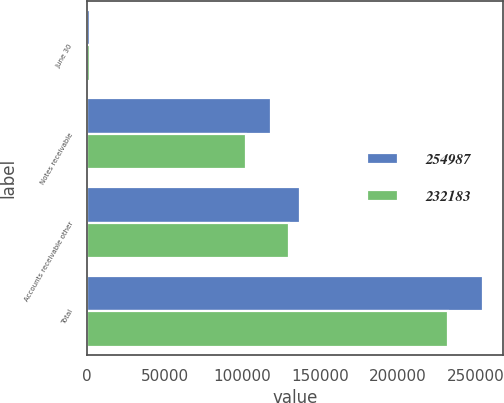Convert chart to OTSL. <chart><loc_0><loc_0><loc_500><loc_500><stacked_bar_chart><ecel><fcel>June 30<fcel>Notes receivable<fcel>Accounts receivable other<fcel>Total<nl><fcel>254987<fcel>2017<fcel>118351<fcel>136636<fcel>254987<nl><fcel>232183<fcel>2016<fcel>102400<fcel>129783<fcel>232183<nl></chart> 